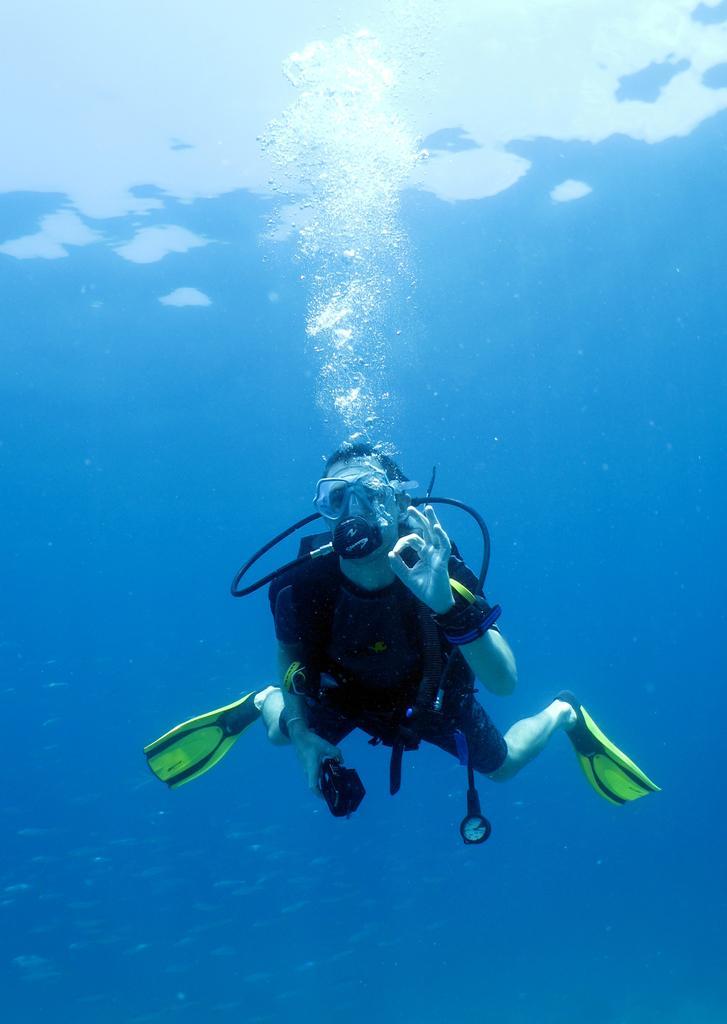How would you summarize this image in a sentence or two? In the image there is a person scuba diving in the ocean. 